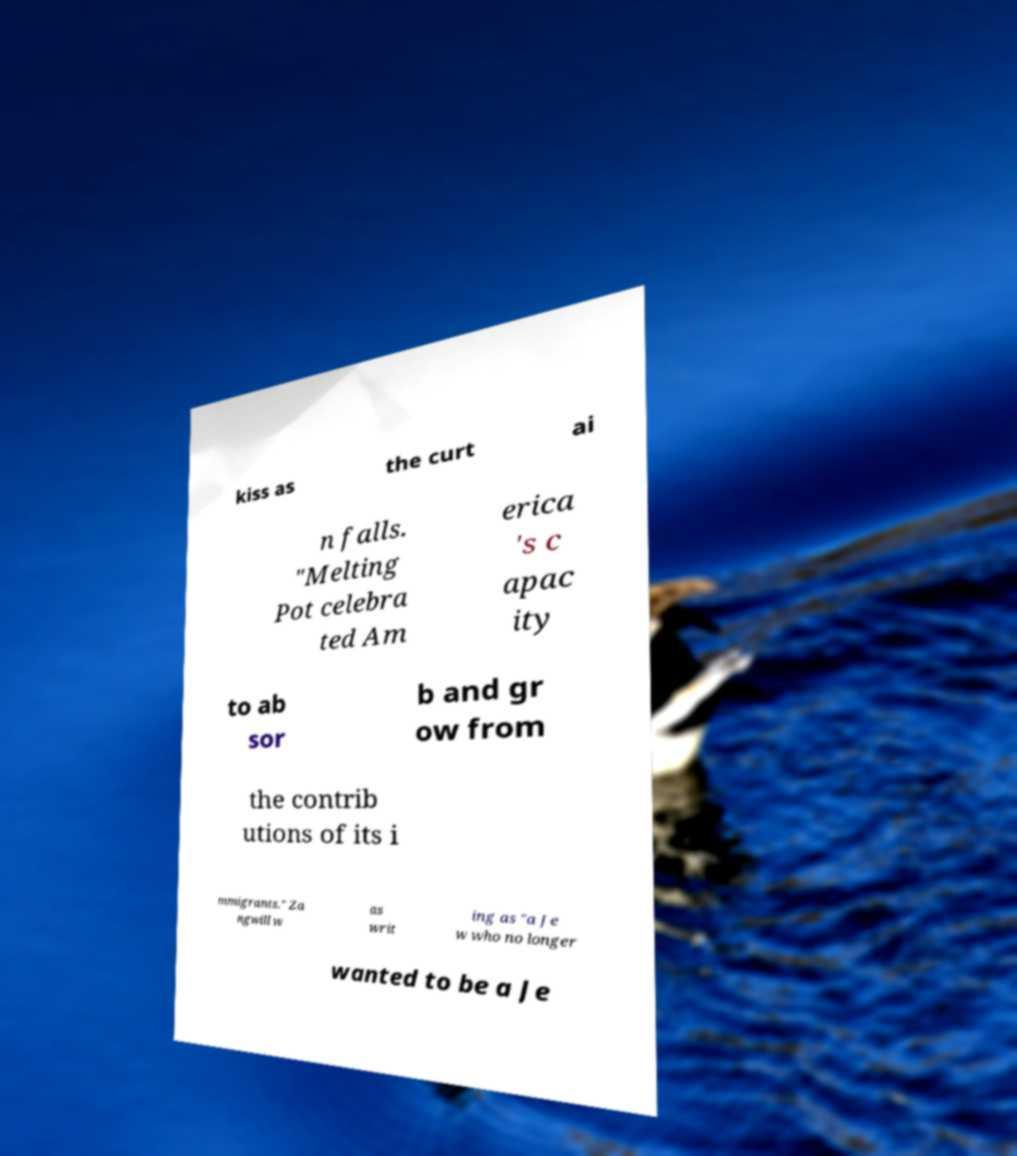Can you accurately transcribe the text from the provided image for me? kiss as the curt ai n falls. "Melting Pot celebra ted Am erica 's c apac ity to ab sor b and gr ow from the contrib utions of its i mmigrants." Za ngwill w as writ ing as "a Je w who no longer wanted to be a Je 